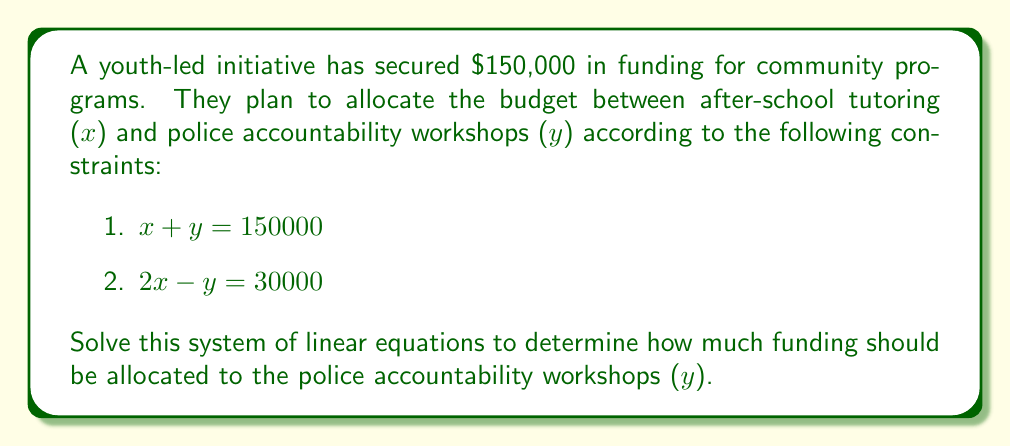Give your solution to this math problem. Let's solve this system of linear equations step-by-step:

1) We have two equations:
   $$x + y = 150000$$ (Equation 1)
   $$2x - y = 30000$$ (Equation 2)

2) Let's add Equation 1 and Equation 2:
   $$(x + y) + (2x - y) = 150000 + 30000$$
   $$3x = 180000$$

3) Solve for $x$:
   $$x = 60000$$

4) Now that we know $x$, we can substitute this value into Equation 1:
   $$60000 + y = 150000$$

5) Solve for $y$:
   $$y = 150000 - 60000 = 90000$$

Therefore, $90,000 should be allocated to the police accountability workshops.
Answer: $90,000 